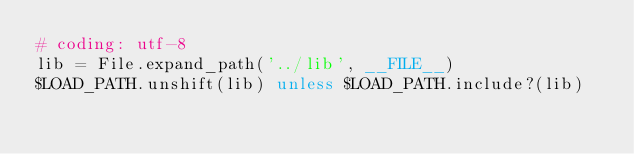<code> <loc_0><loc_0><loc_500><loc_500><_Ruby_># coding: utf-8
lib = File.expand_path('../lib', __FILE__)
$LOAD_PATH.unshift(lib) unless $LOAD_PATH.include?(lib)</code> 